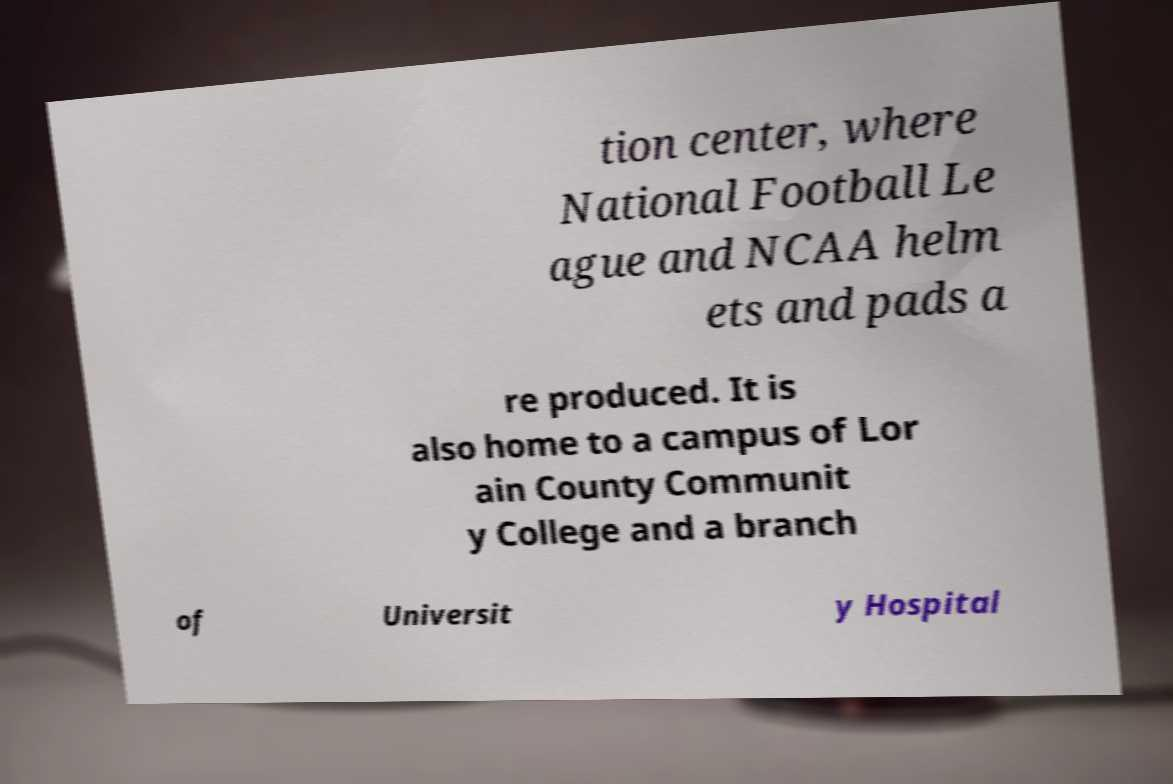Could you extract and type out the text from this image? tion center, where National Football Le ague and NCAA helm ets and pads a re produced. It is also home to a campus of Lor ain County Communit y College and a branch of Universit y Hospital 